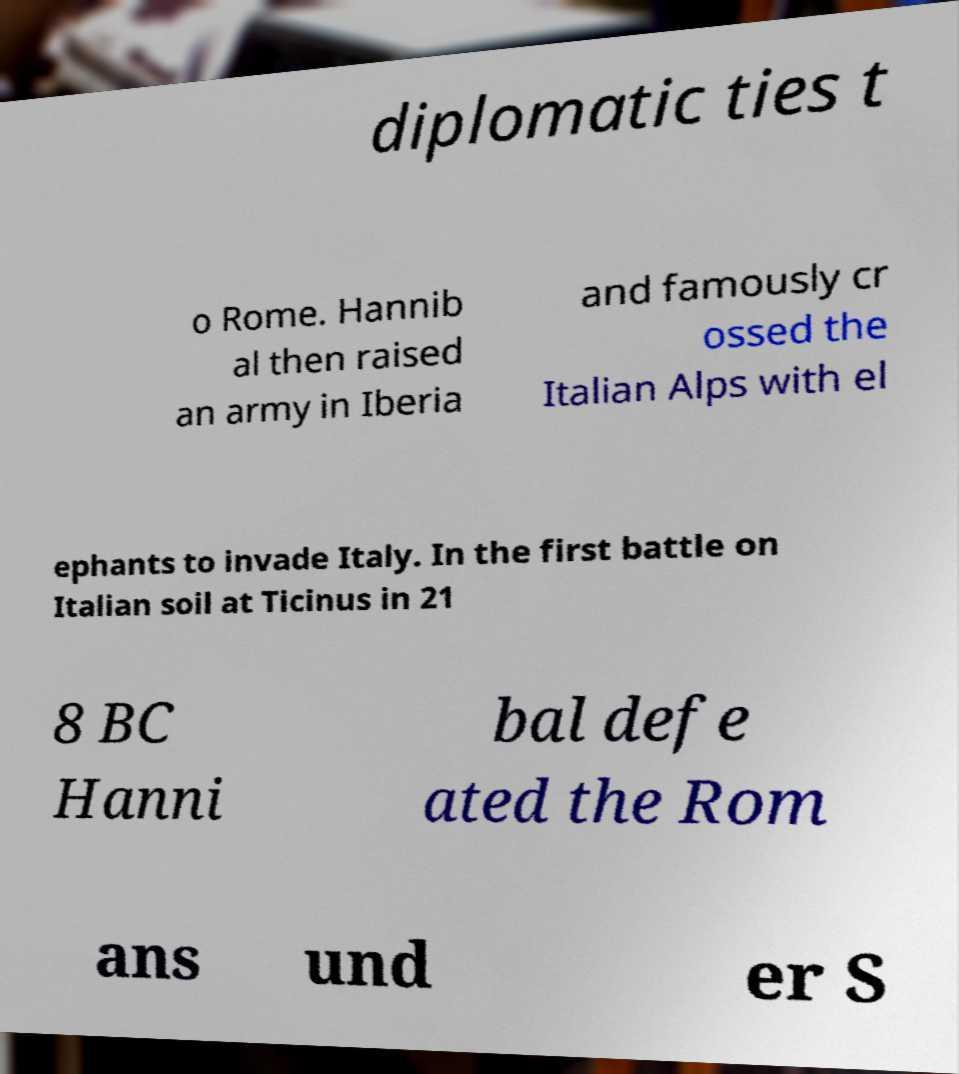There's text embedded in this image that I need extracted. Can you transcribe it verbatim? diplomatic ties t o Rome. Hannib al then raised an army in Iberia and famously cr ossed the Italian Alps with el ephants to invade Italy. In the first battle on Italian soil at Ticinus in 21 8 BC Hanni bal defe ated the Rom ans und er S 